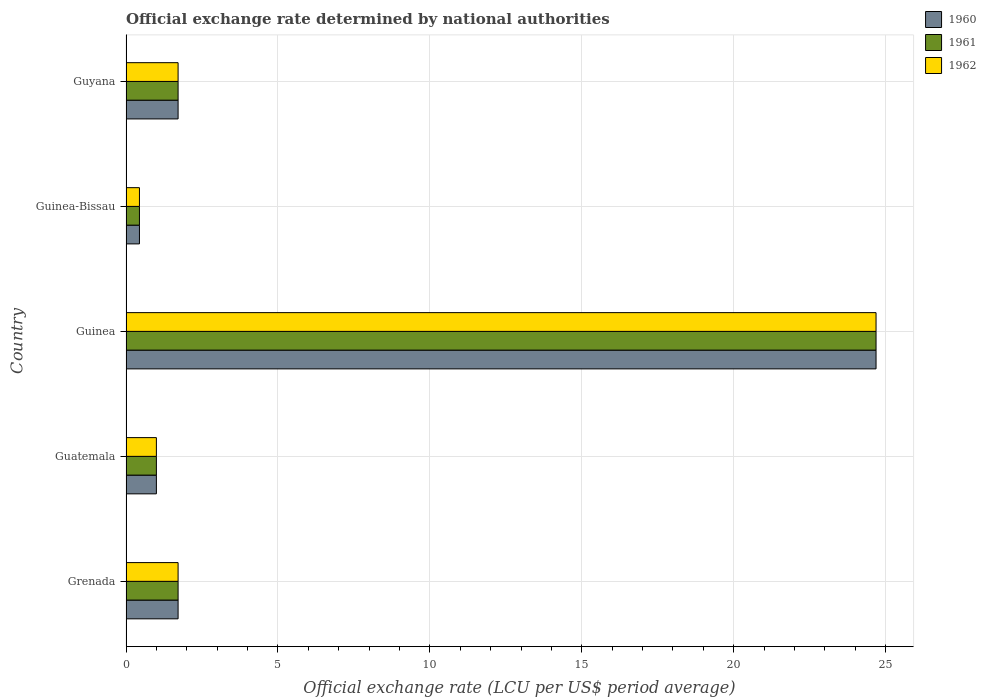How many different coloured bars are there?
Make the answer very short. 3. Are the number of bars per tick equal to the number of legend labels?
Keep it short and to the point. Yes. Are the number of bars on each tick of the Y-axis equal?
Offer a very short reply. Yes. How many bars are there on the 4th tick from the bottom?
Your response must be concise. 3. What is the label of the 2nd group of bars from the top?
Your response must be concise. Guinea-Bissau. In how many cases, is the number of bars for a given country not equal to the number of legend labels?
Your response must be concise. 0. What is the official exchange rate in 1961 in Guyana?
Your response must be concise. 1.71. Across all countries, what is the maximum official exchange rate in 1962?
Your answer should be very brief. 24.69. Across all countries, what is the minimum official exchange rate in 1960?
Your answer should be very brief. 0.44. In which country was the official exchange rate in 1962 maximum?
Keep it short and to the point. Guinea. In which country was the official exchange rate in 1962 minimum?
Provide a short and direct response. Guinea-Bissau. What is the total official exchange rate in 1962 in the graph?
Make the answer very short. 29.56. What is the difference between the official exchange rate in 1960 in Grenada and that in Guinea-Bissau?
Offer a very short reply. 1.27. What is the difference between the official exchange rate in 1961 in Guinea-Bissau and the official exchange rate in 1962 in Guinea?
Give a very brief answer. -24.24. What is the average official exchange rate in 1961 per country?
Provide a succinct answer. 5.91. What is the difference between the official exchange rate in 1962 and official exchange rate in 1961 in Guyana?
Make the answer very short. 0. What is the ratio of the official exchange rate in 1962 in Guatemala to that in Guinea-Bissau?
Offer a very short reply. 2.26. Is the official exchange rate in 1961 in Guinea less than that in Guinea-Bissau?
Your answer should be very brief. No. Is the difference between the official exchange rate in 1962 in Grenada and Guinea greater than the difference between the official exchange rate in 1961 in Grenada and Guinea?
Your answer should be very brief. No. What is the difference between the highest and the second highest official exchange rate in 1961?
Your answer should be compact. 22.97. What is the difference between the highest and the lowest official exchange rate in 1962?
Your answer should be compact. 24.24. In how many countries, is the official exchange rate in 1961 greater than the average official exchange rate in 1961 taken over all countries?
Offer a terse response. 1. What does the 1st bar from the top in Guinea represents?
Offer a terse response. 1962. Is it the case that in every country, the sum of the official exchange rate in 1960 and official exchange rate in 1962 is greater than the official exchange rate in 1961?
Ensure brevity in your answer.  Yes. Are the values on the major ticks of X-axis written in scientific E-notation?
Provide a succinct answer. No. Does the graph contain any zero values?
Ensure brevity in your answer.  No. How many legend labels are there?
Ensure brevity in your answer.  3. What is the title of the graph?
Offer a very short reply. Official exchange rate determined by national authorities. What is the label or title of the X-axis?
Your answer should be compact. Official exchange rate (LCU per US$ period average). What is the Official exchange rate (LCU per US$ period average) in 1960 in Grenada?
Keep it short and to the point. 1.71. What is the Official exchange rate (LCU per US$ period average) of 1961 in Grenada?
Ensure brevity in your answer.  1.71. What is the Official exchange rate (LCU per US$ period average) in 1962 in Grenada?
Provide a short and direct response. 1.71. What is the Official exchange rate (LCU per US$ period average) in 1960 in Guatemala?
Your answer should be compact. 1. What is the Official exchange rate (LCU per US$ period average) in 1961 in Guatemala?
Make the answer very short. 1. What is the Official exchange rate (LCU per US$ period average) of 1960 in Guinea?
Provide a short and direct response. 24.69. What is the Official exchange rate (LCU per US$ period average) of 1961 in Guinea?
Your answer should be compact. 24.69. What is the Official exchange rate (LCU per US$ period average) of 1962 in Guinea?
Your answer should be very brief. 24.69. What is the Official exchange rate (LCU per US$ period average) in 1960 in Guinea-Bissau?
Your answer should be compact. 0.44. What is the Official exchange rate (LCU per US$ period average) in 1961 in Guinea-Bissau?
Ensure brevity in your answer.  0.44. What is the Official exchange rate (LCU per US$ period average) of 1962 in Guinea-Bissau?
Your answer should be very brief. 0.44. What is the Official exchange rate (LCU per US$ period average) of 1960 in Guyana?
Your answer should be compact. 1.71. What is the Official exchange rate (LCU per US$ period average) in 1961 in Guyana?
Offer a terse response. 1.71. What is the Official exchange rate (LCU per US$ period average) of 1962 in Guyana?
Keep it short and to the point. 1.71. Across all countries, what is the maximum Official exchange rate (LCU per US$ period average) in 1960?
Offer a very short reply. 24.69. Across all countries, what is the maximum Official exchange rate (LCU per US$ period average) of 1961?
Offer a terse response. 24.69. Across all countries, what is the maximum Official exchange rate (LCU per US$ period average) in 1962?
Your answer should be very brief. 24.69. Across all countries, what is the minimum Official exchange rate (LCU per US$ period average) in 1960?
Keep it short and to the point. 0.44. Across all countries, what is the minimum Official exchange rate (LCU per US$ period average) of 1961?
Your response must be concise. 0.44. Across all countries, what is the minimum Official exchange rate (LCU per US$ period average) of 1962?
Ensure brevity in your answer.  0.44. What is the total Official exchange rate (LCU per US$ period average) of 1960 in the graph?
Give a very brief answer. 29.56. What is the total Official exchange rate (LCU per US$ period average) in 1961 in the graph?
Give a very brief answer. 29.56. What is the total Official exchange rate (LCU per US$ period average) in 1962 in the graph?
Offer a terse response. 29.56. What is the difference between the Official exchange rate (LCU per US$ period average) of 1961 in Grenada and that in Guatemala?
Your answer should be compact. 0.71. What is the difference between the Official exchange rate (LCU per US$ period average) of 1962 in Grenada and that in Guatemala?
Your answer should be compact. 0.71. What is the difference between the Official exchange rate (LCU per US$ period average) of 1960 in Grenada and that in Guinea?
Provide a short and direct response. -22.97. What is the difference between the Official exchange rate (LCU per US$ period average) in 1961 in Grenada and that in Guinea?
Make the answer very short. -22.97. What is the difference between the Official exchange rate (LCU per US$ period average) in 1962 in Grenada and that in Guinea?
Your response must be concise. -22.97. What is the difference between the Official exchange rate (LCU per US$ period average) of 1960 in Grenada and that in Guinea-Bissau?
Your answer should be compact. 1.27. What is the difference between the Official exchange rate (LCU per US$ period average) in 1961 in Grenada and that in Guinea-Bissau?
Your answer should be compact. 1.27. What is the difference between the Official exchange rate (LCU per US$ period average) in 1962 in Grenada and that in Guinea-Bissau?
Your answer should be very brief. 1.27. What is the difference between the Official exchange rate (LCU per US$ period average) in 1960 in Grenada and that in Guyana?
Ensure brevity in your answer.  0. What is the difference between the Official exchange rate (LCU per US$ period average) of 1961 in Grenada and that in Guyana?
Your answer should be compact. 0. What is the difference between the Official exchange rate (LCU per US$ period average) of 1962 in Grenada and that in Guyana?
Your response must be concise. 0. What is the difference between the Official exchange rate (LCU per US$ period average) in 1960 in Guatemala and that in Guinea?
Ensure brevity in your answer.  -23.68. What is the difference between the Official exchange rate (LCU per US$ period average) in 1961 in Guatemala and that in Guinea?
Provide a short and direct response. -23.68. What is the difference between the Official exchange rate (LCU per US$ period average) of 1962 in Guatemala and that in Guinea?
Offer a very short reply. -23.68. What is the difference between the Official exchange rate (LCU per US$ period average) of 1960 in Guatemala and that in Guinea-Bissau?
Your answer should be compact. 0.56. What is the difference between the Official exchange rate (LCU per US$ period average) in 1961 in Guatemala and that in Guinea-Bissau?
Ensure brevity in your answer.  0.56. What is the difference between the Official exchange rate (LCU per US$ period average) in 1962 in Guatemala and that in Guinea-Bissau?
Ensure brevity in your answer.  0.56. What is the difference between the Official exchange rate (LCU per US$ period average) in 1960 in Guatemala and that in Guyana?
Ensure brevity in your answer.  -0.71. What is the difference between the Official exchange rate (LCU per US$ period average) in 1961 in Guatemala and that in Guyana?
Offer a very short reply. -0.71. What is the difference between the Official exchange rate (LCU per US$ period average) in 1962 in Guatemala and that in Guyana?
Keep it short and to the point. -0.71. What is the difference between the Official exchange rate (LCU per US$ period average) in 1960 in Guinea and that in Guinea-Bissau?
Your answer should be compact. 24.24. What is the difference between the Official exchange rate (LCU per US$ period average) of 1961 in Guinea and that in Guinea-Bissau?
Ensure brevity in your answer.  24.24. What is the difference between the Official exchange rate (LCU per US$ period average) in 1962 in Guinea and that in Guinea-Bissau?
Make the answer very short. 24.24. What is the difference between the Official exchange rate (LCU per US$ period average) of 1960 in Guinea and that in Guyana?
Ensure brevity in your answer.  22.97. What is the difference between the Official exchange rate (LCU per US$ period average) of 1961 in Guinea and that in Guyana?
Give a very brief answer. 22.97. What is the difference between the Official exchange rate (LCU per US$ period average) of 1962 in Guinea and that in Guyana?
Offer a terse response. 22.97. What is the difference between the Official exchange rate (LCU per US$ period average) in 1960 in Guinea-Bissau and that in Guyana?
Provide a short and direct response. -1.27. What is the difference between the Official exchange rate (LCU per US$ period average) in 1961 in Guinea-Bissau and that in Guyana?
Your answer should be compact. -1.27. What is the difference between the Official exchange rate (LCU per US$ period average) of 1962 in Guinea-Bissau and that in Guyana?
Your answer should be compact. -1.27. What is the difference between the Official exchange rate (LCU per US$ period average) of 1961 in Grenada and the Official exchange rate (LCU per US$ period average) of 1962 in Guatemala?
Offer a very short reply. 0.71. What is the difference between the Official exchange rate (LCU per US$ period average) of 1960 in Grenada and the Official exchange rate (LCU per US$ period average) of 1961 in Guinea?
Provide a short and direct response. -22.97. What is the difference between the Official exchange rate (LCU per US$ period average) of 1960 in Grenada and the Official exchange rate (LCU per US$ period average) of 1962 in Guinea?
Make the answer very short. -22.97. What is the difference between the Official exchange rate (LCU per US$ period average) of 1961 in Grenada and the Official exchange rate (LCU per US$ period average) of 1962 in Guinea?
Your answer should be very brief. -22.97. What is the difference between the Official exchange rate (LCU per US$ period average) of 1960 in Grenada and the Official exchange rate (LCU per US$ period average) of 1961 in Guinea-Bissau?
Provide a short and direct response. 1.27. What is the difference between the Official exchange rate (LCU per US$ period average) of 1960 in Grenada and the Official exchange rate (LCU per US$ period average) of 1962 in Guinea-Bissau?
Offer a very short reply. 1.27. What is the difference between the Official exchange rate (LCU per US$ period average) of 1961 in Grenada and the Official exchange rate (LCU per US$ period average) of 1962 in Guinea-Bissau?
Your answer should be very brief. 1.27. What is the difference between the Official exchange rate (LCU per US$ period average) in 1960 in Grenada and the Official exchange rate (LCU per US$ period average) in 1962 in Guyana?
Keep it short and to the point. 0. What is the difference between the Official exchange rate (LCU per US$ period average) in 1960 in Guatemala and the Official exchange rate (LCU per US$ period average) in 1961 in Guinea?
Make the answer very short. -23.68. What is the difference between the Official exchange rate (LCU per US$ period average) of 1960 in Guatemala and the Official exchange rate (LCU per US$ period average) of 1962 in Guinea?
Offer a very short reply. -23.68. What is the difference between the Official exchange rate (LCU per US$ period average) of 1961 in Guatemala and the Official exchange rate (LCU per US$ period average) of 1962 in Guinea?
Offer a terse response. -23.68. What is the difference between the Official exchange rate (LCU per US$ period average) in 1960 in Guatemala and the Official exchange rate (LCU per US$ period average) in 1961 in Guinea-Bissau?
Keep it short and to the point. 0.56. What is the difference between the Official exchange rate (LCU per US$ period average) of 1960 in Guatemala and the Official exchange rate (LCU per US$ period average) of 1962 in Guinea-Bissau?
Your answer should be compact. 0.56. What is the difference between the Official exchange rate (LCU per US$ period average) of 1961 in Guatemala and the Official exchange rate (LCU per US$ period average) of 1962 in Guinea-Bissau?
Provide a short and direct response. 0.56. What is the difference between the Official exchange rate (LCU per US$ period average) of 1960 in Guatemala and the Official exchange rate (LCU per US$ period average) of 1961 in Guyana?
Make the answer very short. -0.71. What is the difference between the Official exchange rate (LCU per US$ period average) in 1960 in Guatemala and the Official exchange rate (LCU per US$ period average) in 1962 in Guyana?
Offer a terse response. -0.71. What is the difference between the Official exchange rate (LCU per US$ period average) of 1961 in Guatemala and the Official exchange rate (LCU per US$ period average) of 1962 in Guyana?
Your response must be concise. -0.71. What is the difference between the Official exchange rate (LCU per US$ period average) in 1960 in Guinea and the Official exchange rate (LCU per US$ period average) in 1961 in Guinea-Bissau?
Keep it short and to the point. 24.24. What is the difference between the Official exchange rate (LCU per US$ period average) of 1960 in Guinea and the Official exchange rate (LCU per US$ period average) of 1962 in Guinea-Bissau?
Your response must be concise. 24.24. What is the difference between the Official exchange rate (LCU per US$ period average) in 1961 in Guinea and the Official exchange rate (LCU per US$ period average) in 1962 in Guinea-Bissau?
Ensure brevity in your answer.  24.24. What is the difference between the Official exchange rate (LCU per US$ period average) of 1960 in Guinea and the Official exchange rate (LCU per US$ period average) of 1961 in Guyana?
Provide a succinct answer. 22.97. What is the difference between the Official exchange rate (LCU per US$ period average) in 1960 in Guinea and the Official exchange rate (LCU per US$ period average) in 1962 in Guyana?
Offer a very short reply. 22.97. What is the difference between the Official exchange rate (LCU per US$ period average) in 1961 in Guinea and the Official exchange rate (LCU per US$ period average) in 1962 in Guyana?
Ensure brevity in your answer.  22.97. What is the difference between the Official exchange rate (LCU per US$ period average) in 1960 in Guinea-Bissau and the Official exchange rate (LCU per US$ period average) in 1961 in Guyana?
Your response must be concise. -1.27. What is the difference between the Official exchange rate (LCU per US$ period average) of 1960 in Guinea-Bissau and the Official exchange rate (LCU per US$ period average) of 1962 in Guyana?
Keep it short and to the point. -1.27. What is the difference between the Official exchange rate (LCU per US$ period average) in 1961 in Guinea-Bissau and the Official exchange rate (LCU per US$ period average) in 1962 in Guyana?
Provide a succinct answer. -1.27. What is the average Official exchange rate (LCU per US$ period average) in 1960 per country?
Ensure brevity in your answer.  5.91. What is the average Official exchange rate (LCU per US$ period average) of 1961 per country?
Provide a short and direct response. 5.91. What is the average Official exchange rate (LCU per US$ period average) in 1962 per country?
Your answer should be very brief. 5.91. What is the difference between the Official exchange rate (LCU per US$ period average) of 1960 and Official exchange rate (LCU per US$ period average) of 1961 in Grenada?
Keep it short and to the point. 0. What is the difference between the Official exchange rate (LCU per US$ period average) of 1960 and Official exchange rate (LCU per US$ period average) of 1961 in Guatemala?
Provide a succinct answer. 0. What is the difference between the Official exchange rate (LCU per US$ period average) of 1961 and Official exchange rate (LCU per US$ period average) of 1962 in Guatemala?
Make the answer very short. 0. What is the difference between the Official exchange rate (LCU per US$ period average) of 1960 and Official exchange rate (LCU per US$ period average) of 1961 in Guinea?
Provide a succinct answer. 0. What is the difference between the Official exchange rate (LCU per US$ period average) of 1960 and Official exchange rate (LCU per US$ period average) of 1962 in Guinea?
Offer a terse response. 0. What is the difference between the Official exchange rate (LCU per US$ period average) of 1961 and Official exchange rate (LCU per US$ period average) of 1962 in Guinea?
Your answer should be very brief. 0. What is the difference between the Official exchange rate (LCU per US$ period average) in 1960 and Official exchange rate (LCU per US$ period average) in 1962 in Guinea-Bissau?
Provide a short and direct response. 0. What is the difference between the Official exchange rate (LCU per US$ period average) of 1961 and Official exchange rate (LCU per US$ period average) of 1962 in Guinea-Bissau?
Give a very brief answer. 0. What is the difference between the Official exchange rate (LCU per US$ period average) in 1961 and Official exchange rate (LCU per US$ period average) in 1962 in Guyana?
Your answer should be very brief. 0. What is the ratio of the Official exchange rate (LCU per US$ period average) in 1960 in Grenada to that in Guatemala?
Provide a short and direct response. 1.71. What is the ratio of the Official exchange rate (LCU per US$ period average) in 1961 in Grenada to that in Guatemala?
Your response must be concise. 1.71. What is the ratio of the Official exchange rate (LCU per US$ period average) of 1962 in Grenada to that in Guatemala?
Offer a terse response. 1.71. What is the ratio of the Official exchange rate (LCU per US$ period average) of 1960 in Grenada to that in Guinea?
Keep it short and to the point. 0.07. What is the ratio of the Official exchange rate (LCU per US$ period average) of 1961 in Grenada to that in Guinea?
Your response must be concise. 0.07. What is the ratio of the Official exchange rate (LCU per US$ period average) of 1962 in Grenada to that in Guinea?
Keep it short and to the point. 0.07. What is the ratio of the Official exchange rate (LCU per US$ period average) of 1960 in Grenada to that in Guinea-Bissau?
Offer a terse response. 3.88. What is the ratio of the Official exchange rate (LCU per US$ period average) in 1961 in Grenada to that in Guinea-Bissau?
Offer a very short reply. 3.88. What is the ratio of the Official exchange rate (LCU per US$ period average) of 1962 in Grenada to that in Guinea-Bissau?
Provide a succinct answer. 3.88. What is the ratio of the Official exchange rate (LCU per US$ period average) of 1961 in Grenada to that in Guyana?
Your answer should be compact. 1. What is the ratio of the Official exchange rate (LCU per US$ period average) of 1962 in Grenada to that in Guyana?
Your answer should be compact. 1. What is the ratio of the Official exchange rate (LCU per US$ period average) of 1960 in Guatemala to that in Guinea?
Your answer should be very brief. 0.04. What is the ratio of the Official exchange rate (LCU per US$ period average) of 1961 in Guatemala to that in Guinea?
Your answer should be very brief. 0.04. What is the ratio of the Official exchange rate (LCU per US$ period average) of 1962 in Guatemala to that in Guinea?
Your answer should be compact. 0.04. What is the ratio of the Official exchange rate (LCU per US$ period average) of 1960 in Guatemala to that in Guinea-Bissau?
Make the answer very short. 2.26. What is the ratio of the Official exchange rate (LCU per US$ period average) of 1961 in Guatemala to that in Guinea-Bissau?
Give a very brief answer. 2.26. What is the ratio of the Official exchange rate (LCU per US$ period average) in 1962 in Guatemala to that in Guinea-Bissau?
Offer a very short reply. 2.26. What is the ratio of the Official exchange rate (LCU per US$ period average) of 1960 in Guatemala to that in Guyana?
Ensure brevity in your answer.  0.58. What is the ratio of the Official exchange rate (LCU per US$ period average) in 1961 in Guatemala to that in Guyana?
Offer a very short reply. 0.58. What is the ratio of the Official exchange rate (LCU per US$ period average) in 1962 in Guatemala to that in Guyana?
Your answer should be very brief. 0.58. What is the ratio of the Official exchange rate (LCU per US$ period average) of 1960 in Guinea to that in Guinea-Bissau?
Ensure brevity in your answer.  55.81. What is the ratio of the Official exchange rate (LCU per US$ period average) in 1961 in Guinea to that in Guinea-Bissau?
Your answer should be compact. 55.81. What is the ratio of the Official exchange rate (LCU per US$ period average) of 1962 in Guinea to that in Guinea-Bissau?
Provide a succinct answer. 55.81. What is the ratio of the Official exchange rate (LCU per US$ period average) of 1960 in Guinea to that in Guyana?
Your answer should be compact. 14.4. What is the ratio of the Official exchange rate (LCU per US$ period average) of 1961 in Guinea to that in Guyana?
Offer a terse response. 14.4. What is the ratio of the Official exchange rate (LCU per US$ period average) in 1962 in Guinea to that in Guyana?
Keep it short and to the point. 14.4. What is the ratio of the Official exchange rate (LCU per US$ period average) in 1960 in Guinea-Bissau to that in Guyana?
Make the answer very short. 0.26. What is the ratio of the Official exchange rate (LCU per US$ period average) of 1961 in Guinea-Bissau to that in Guyana?
Ensure brevity in your answer.  0.26. What is the ratio of the Official exchange rate (LCU per US$ period average) of 1962 in Guinea-Bissau to that in Guyana?
Your answer should be compact. 0.26. What is the difference between the highest and the second highest Official exchange rate (LCU per US$ period average) of 1960?
Your response must be concise. 22.97. What is the difference between the highest and the second highest Official exchange rate (LCU per US$ period average) in 1961?
Provide a succinct answer. 22.97. What is the difference between the highest and the second highest Official exchange rate (LCU per US$ period average) of 1962?
Your answer should be compact. 22.97. What is the difference between the highest and the lowest Official exchange rate (LCU per US$ period average) in 1960?
Keep it short and to the point. 24.24. What is the difference between the highest and the lowest Official exchange rate (LCU per US$ period average) in 1961?
Offer a terse response. 24.24. What is the difference between the highest and the lowest Official exchange rate (LCU per US$ period average) of 1962?
Make the answer very short. 24.24. 